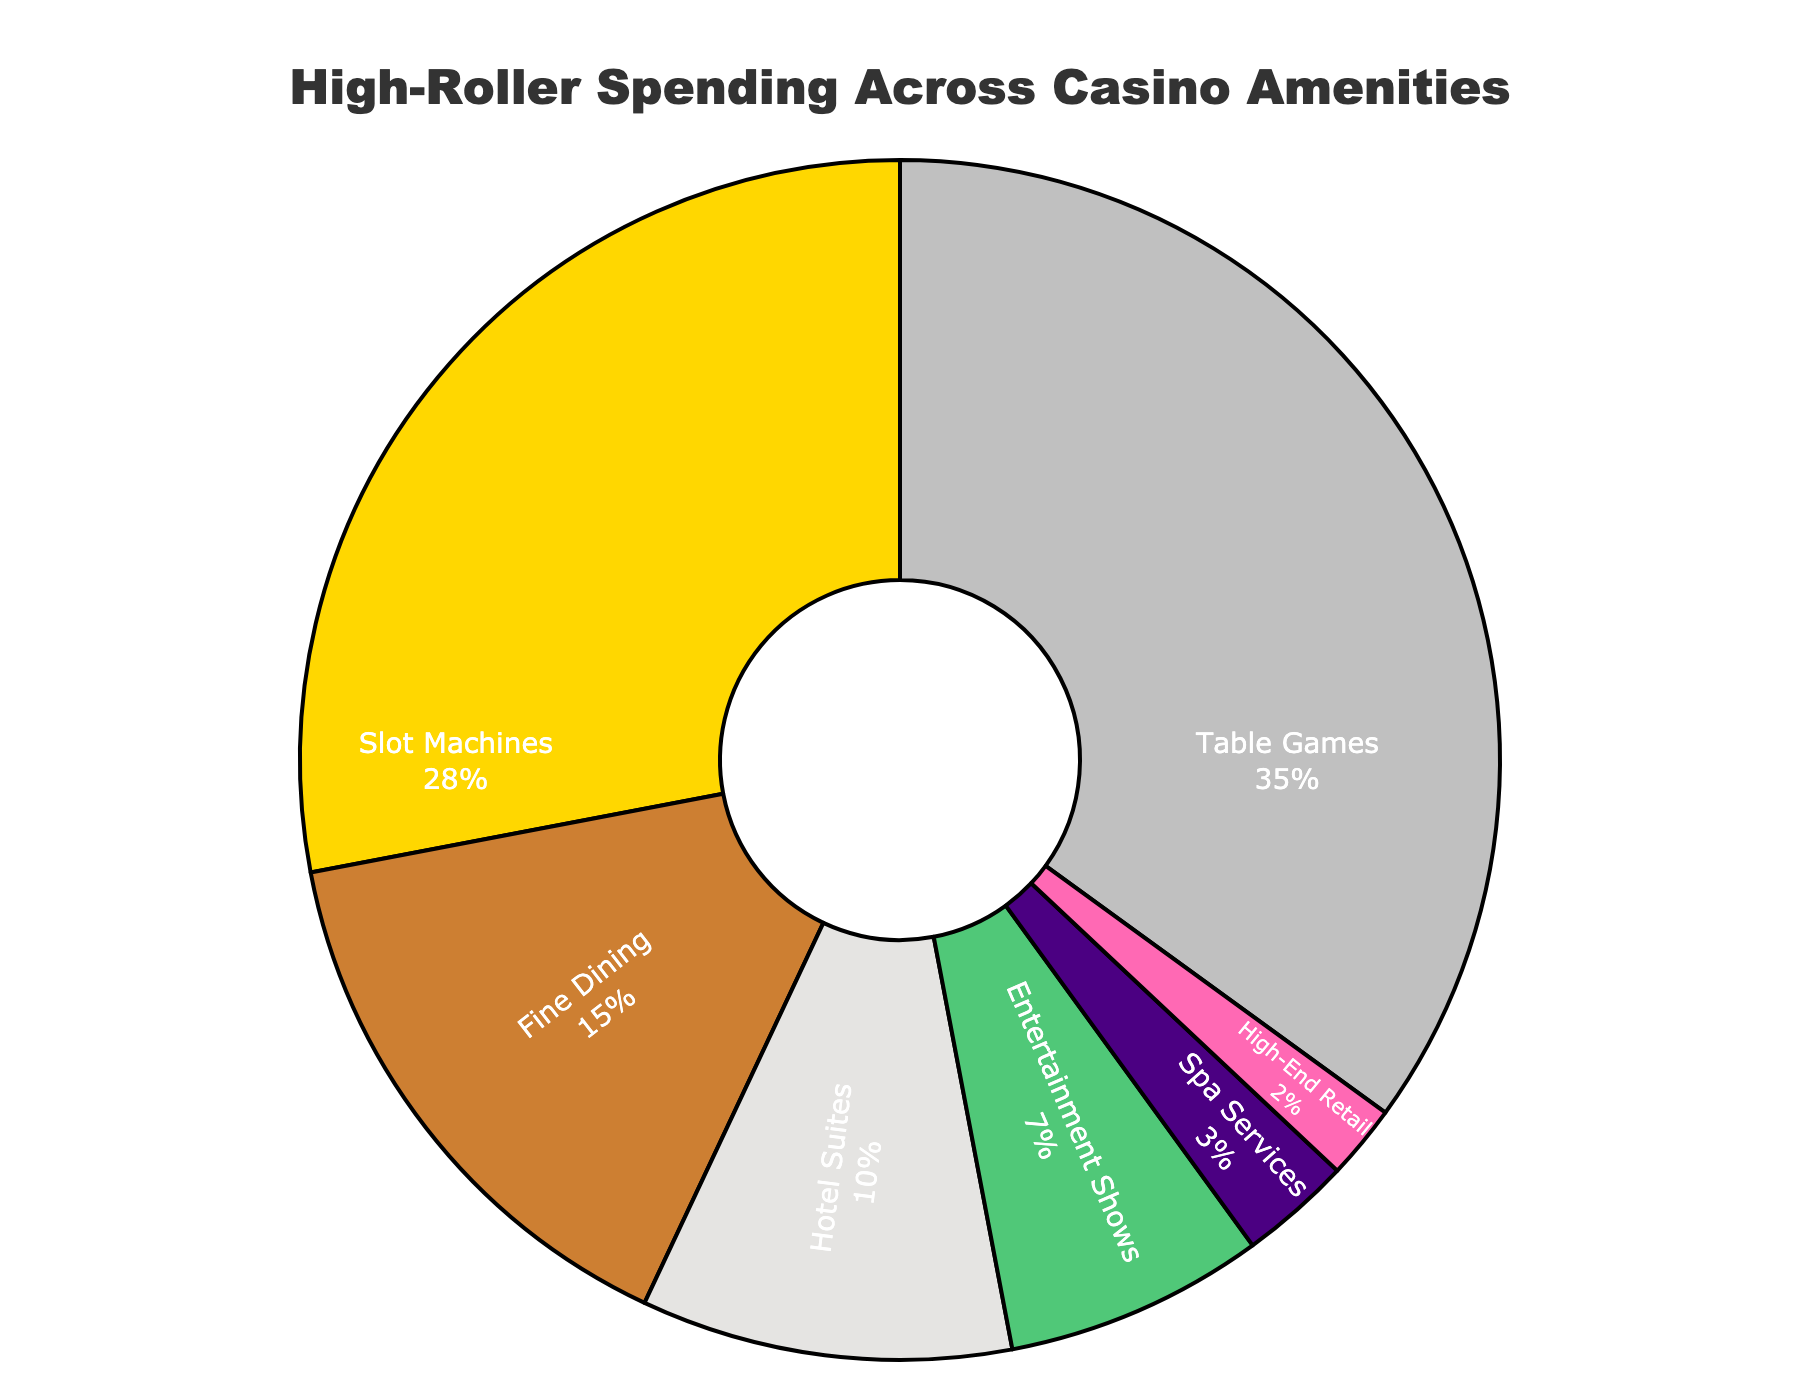What category receives the largest percentage of spending? The pie chart shows the breakdown of high-roller spending across various casino amenities. The segment labeled "Table Games" is the largest, indicating that it receives the highest percentage of spending.
Answer: Table Games What percentage of spending is devoted to Slot Machines and Entertainment Shows combined? Slot Machines account for 28% and Entertainment Shows account for 7%. Adding these together: 28% + 7% = 35%.
Answer: 35% How much more is spent on Fine Dining compared to Spa Services? Fine Dining has a slice representing 15%, while Spa Services have a slice representing 3%. The difference is calculated as 15% - 3% = 12%.
Answer: 12% Which two categories have the smallest shares of spending, and what is their combined percentage? "High-End Retail" accounts for 2% and "Spa Services" account for 3%. The combined percentage is 2% + 3% = 5%.
Answer: High-End Retail and Spa Services, 5% Is the percentage of spending on Hotel Suites greater than the sum of spending on Spa Services and High-End Retail? Hotel Suites account for 10%, while the sum of spending on Spa Services (3%) and High-End Retail (2%) is 3% + 2% = 5%. Comparing these, 10% is greater than 5%.
Answer: Yes Identify the third largest category of spending. The pie chart segments can be ordered by size. "Table Games" is the largest (35%), followed by "Slot Machines" (28%), making "Fine Dining" the third largest with 15%.
Answer: Fine Dining What is the total percentage of spending on non-gaming amenities? Non-gaming amenities include Fine Dining (15%), Hotel Suites (10%), Entertainment Shows (7%), Spa Services (3%), and High-End Retail (2%). Adding these: 15% + 10% + 7% + 3% + 2% = 37%.
Answer: 37% What is the ratio of spending on Table Games to Slot Machines? Table Games account for 35% and Slot Machines for 28%. The ratio is 35:28, which simplifies to 5:4.
Answer: 5:4 How does the spending on Entertainment Shows compare to Fine Dining? Entertainment Shows account for 7% and Fine Dining for 15%. Since 7% is less than 15%, spending on Entertainment Shows is less.
Answer: Less If the total spending is $1,000,000, how much is spent on Table Games? Table Games account for 35% of the total. Calculating 35% of $1,000,000: (35/100) * $1,000,000 = $350,000.
Answer: $350,000 